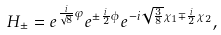<formula> <loc_0><loc_0><loc_500><loc_500>H _ { \pm } & = e ^ { \frac { i } { \sqrt { 8 } } \varphi } e ^ { \pm \frac { i } { 2 } \phi } e ^ { - i \sqrt { \frac { 3 } { 8 } } \chi _ { 1 } \mp \frac { i } { 2 } \chi _ { 2 } } ,</formula> 